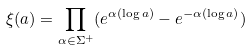<formula> <loc_0><loc_0><loc_500><loc_500>\xi ( a ) = \prod _ { \alpha \in \Sigma ^ { + } } ( e ^ { \alpha ( \log a ) } - e ^ { - \alpha ( \log a ) } )</formula> 